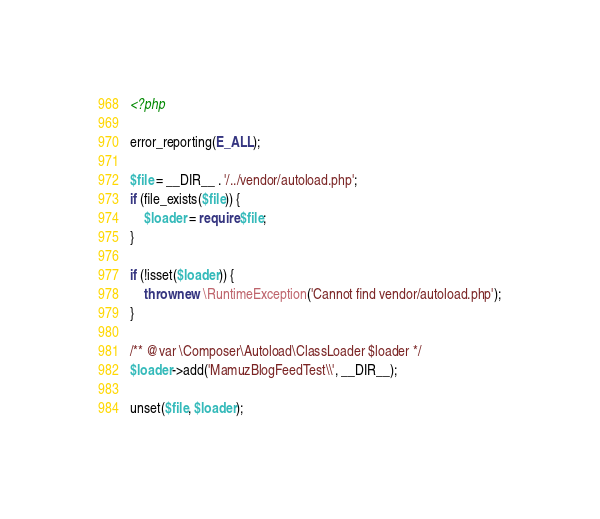Convert code to text. <code><loc_0><loc_0><loc_500><loc_500><_PHP_><?php

error_reporting(E_ALL);

$file = __DIR__ . '/../vendor/autoload.php';
if (file_exists($file)) {
    $loader = require $file;
}

if (!isset($loader)) {
    throw new \RuntimeException('Cannot find vendor/autoload.php');
}

/** @var \Composer\Autoload\ClassLoader $loader */
$loader->add('MamuzBlogFeedTest\\', __DIR__);

unset($file, $loader);
</code> 